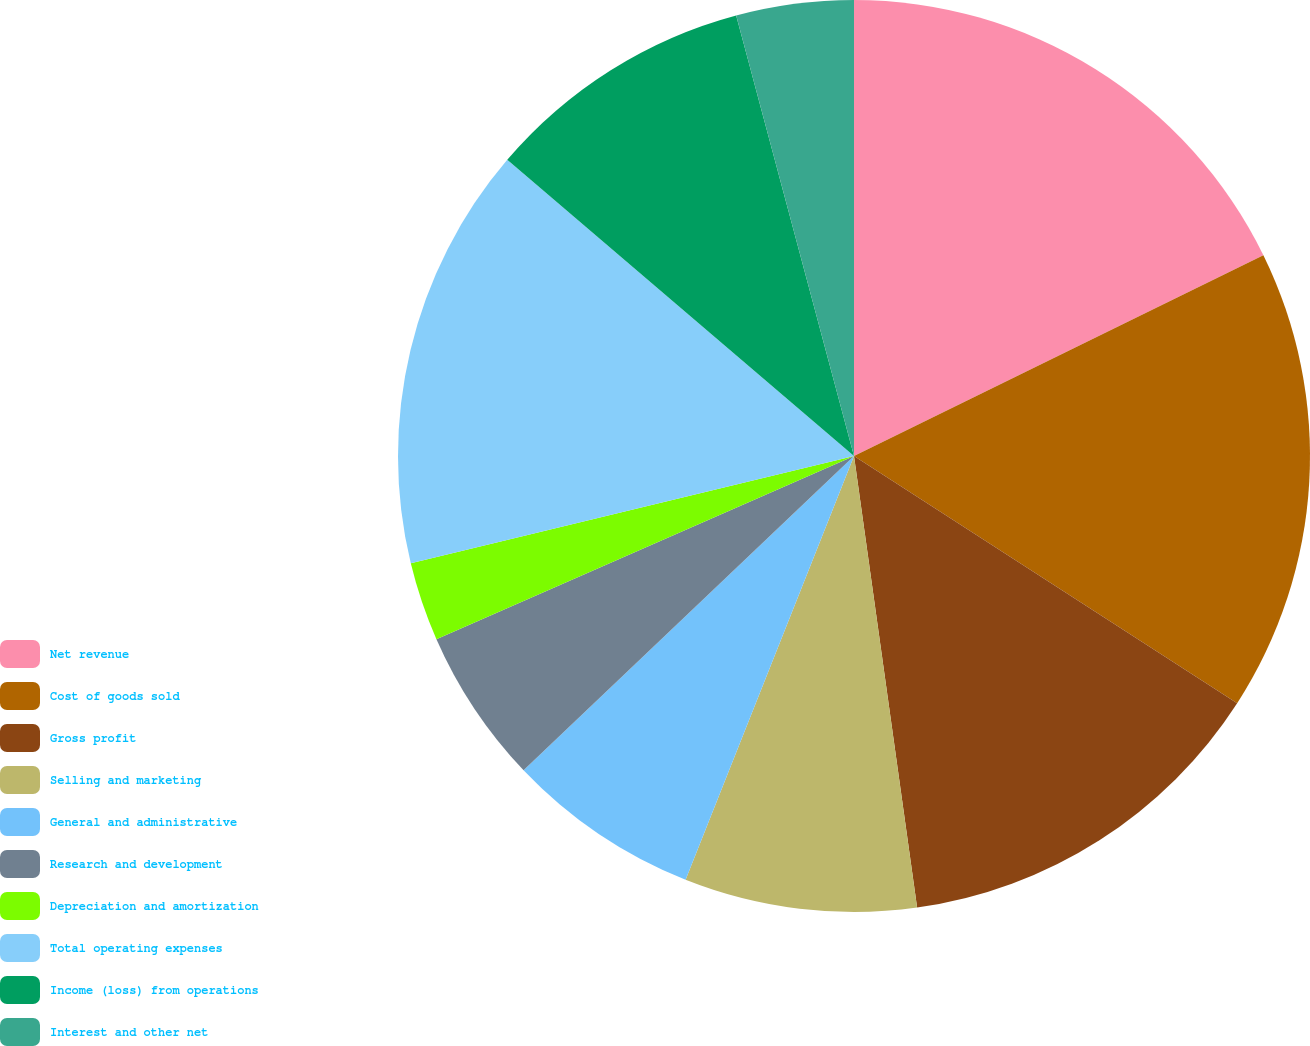<chart> <loc_0><loc_0><loc_500><loc_500><pie_chart><fcel>Net revenue<fcel>Cost of goods sold<fcel>Gross profit<fcel>Selling and marketing<fcel>General and administrative<fcel>Research and development<fcel>Depreciation and amortization<fcel>Total operating expenses<fcel>Income (loss) from operations<fcel>Interest and other net<nl><fcel>17.74%<fcel>16.38%<fcel>13.67%<fcel>8.23%<fcel>6.88%<fcel>5.52%<fcel>2.8%<fcel>15.03%<fcel>9.59%<fcel>4.16%<nl></chart> 